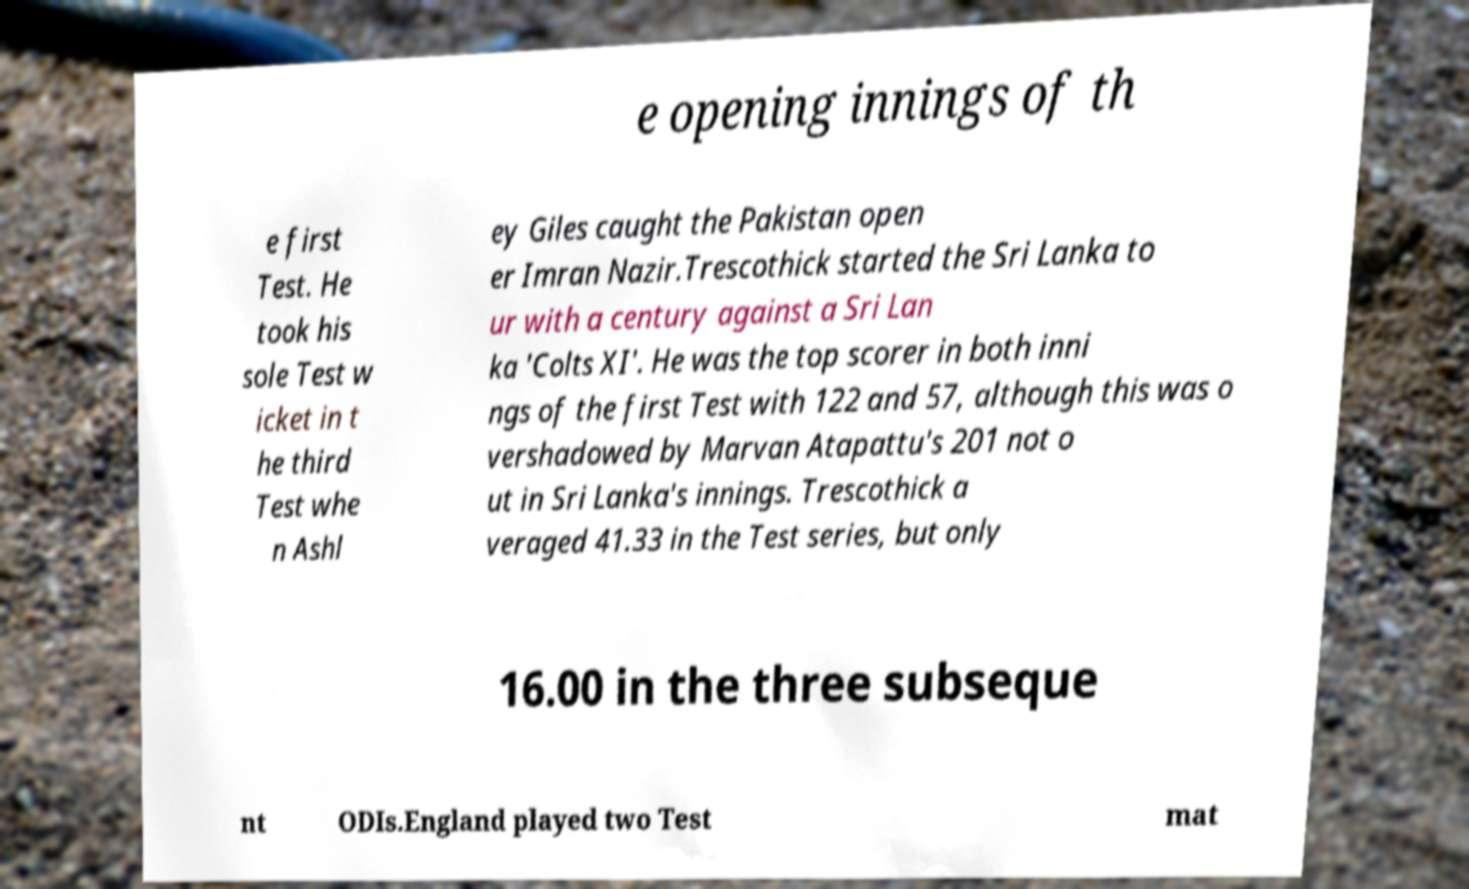Please read and relay the text visible in this image. What does it say? e opening innings of th e first Test. He took his sole Test w icket in t he third Test whe n Ashl ey Giles caught the Pakistan open er Imran Nazir.Trescothick started the Sri Lanka to ur with a century against a Sri Lan ka 'Colts XI'. He was the top scorer in both inni ngs of the first Test with 122 and 57, although this was o vershadowed by Marvan Atapattu's 201 not o ut in Sri Lanka's innings. Trescothick a veraged 41.33 in the Test series, but only 16.00 in the three subseque nt ODIs.England played two Test mat 